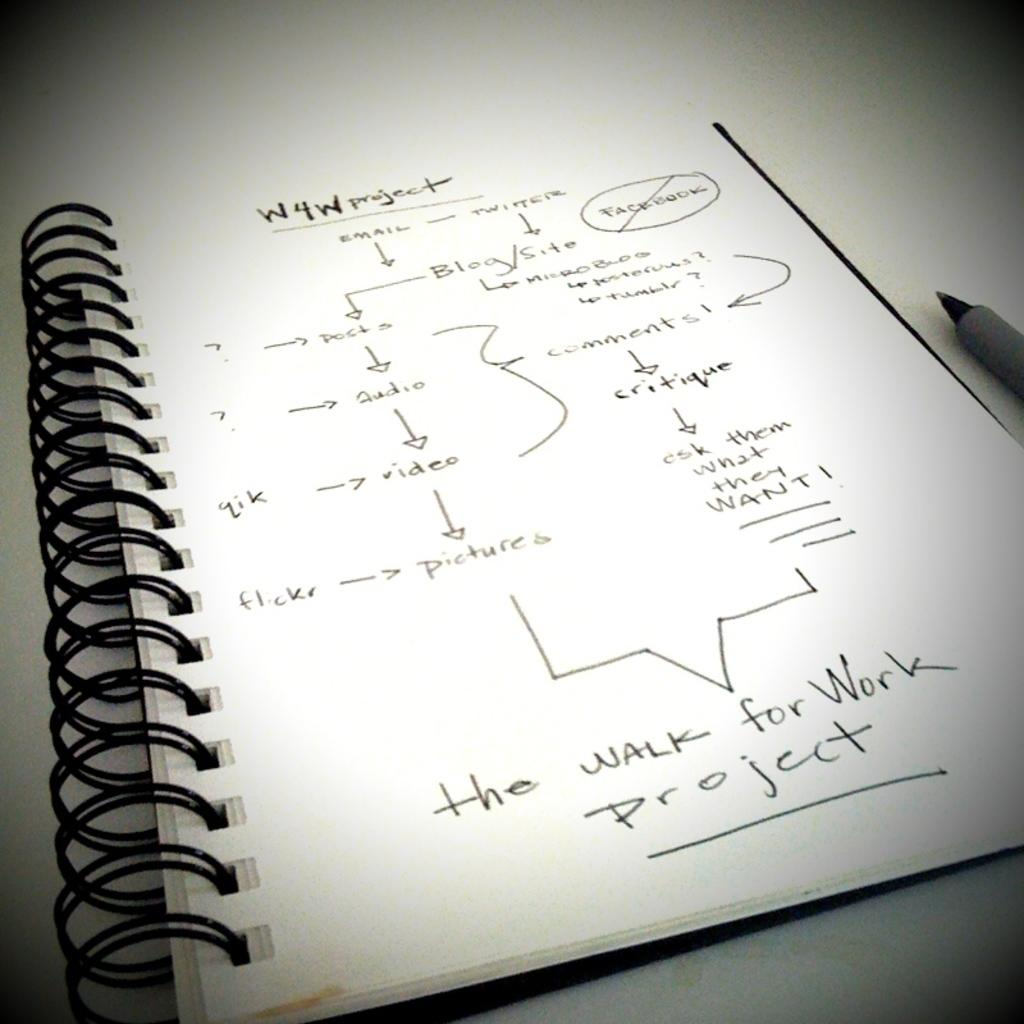<image>
Share a concise interpretation of the image provided. A notebook with the W4W project details listed on a page 